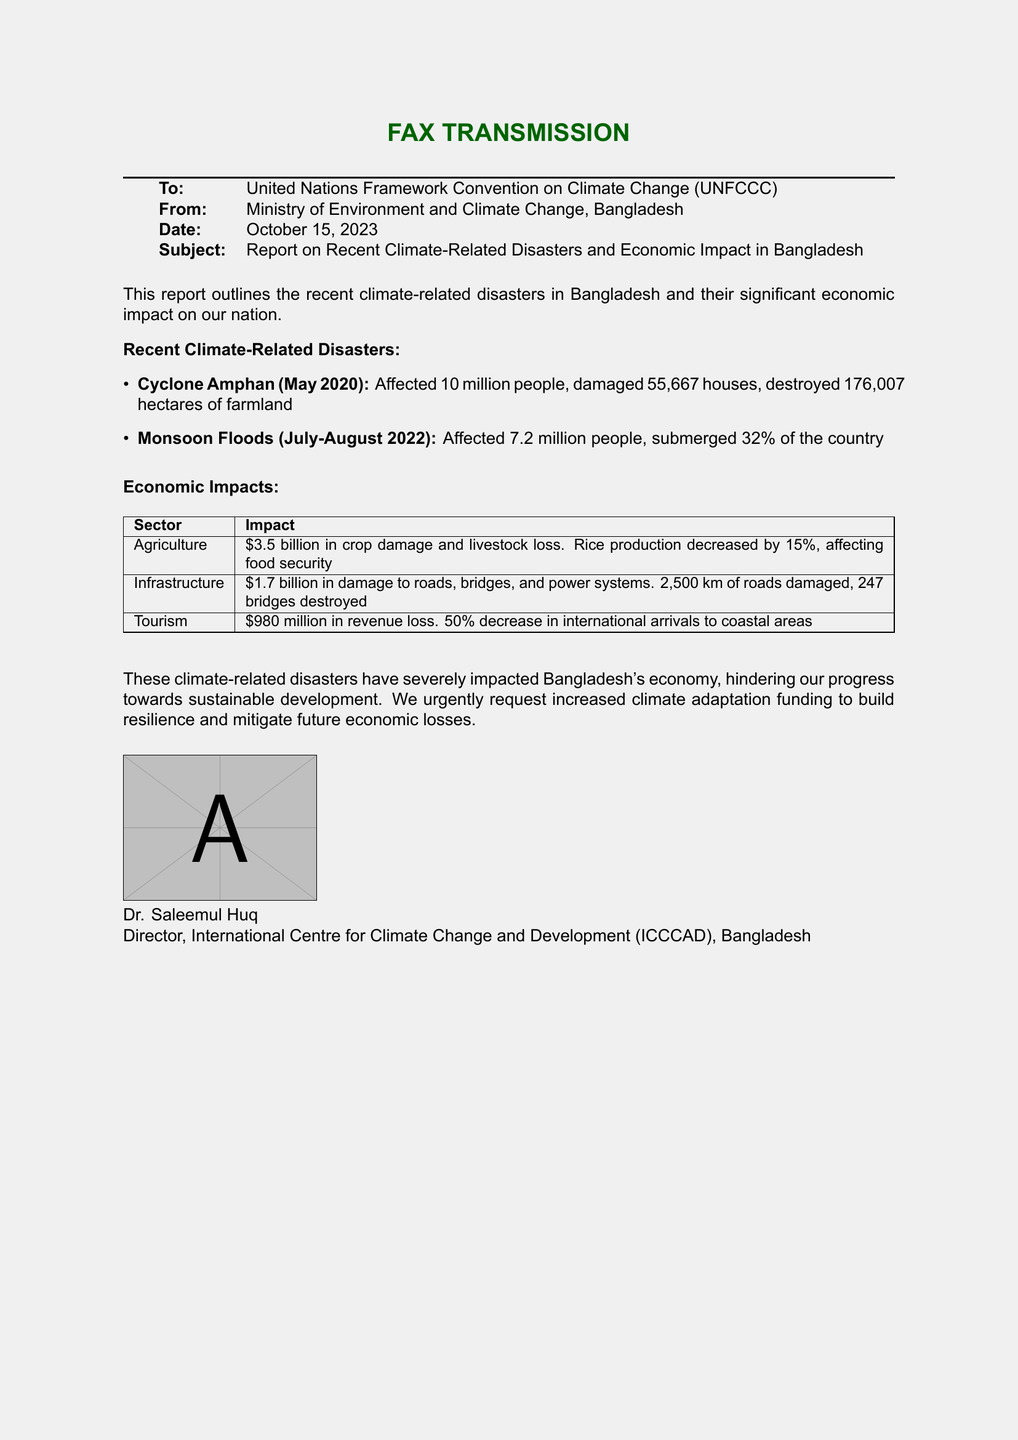what is the title of the report? The title is stated at the beginning of the report, which details climate-related disasters and economic impacts.
Answer: Report on Recent Climate-Related Disasters and Economic Impact in Bangladesh who is the sender of the fax? The sender is indicated in the header section of the document, specifying the governmental agency involved.
Answer: Ministry of Environment and Climate Change, Bangladesh when did Cyclone Amphan occur? The date of Cyclone Amphan is mentioned clearly under the recent climate-related disasters section.
Answer: May 2020 how many people were affected by the monsoon floods? The number of people affected is provided in the description of the monsoon floods event.
Answer: 7.2 million people what is the economic impact on agriculture? The impact on agriculture includes specific financial losses stated in the economic impacts table.
Answer: $3.5 billion in crop damage and livestock loss which sector experienced a $980 million revenue loss? The specific sector is noted in the economic impacts table under the corresponding loss amount.
Answer: Tourism what percentage of international arrivals to coastal areas decreased? The percentage decrease is provided in the tourism impact description.
Answer: 50% what is the total damage to infrastructure? The total damage to infrastructure is summarized in the economic impacts table.
Answer: $1.7 billion what is the request made by Bangladesh in the report? The report concludes with a request for funding, explicitly asking for support related to climate issues.
Answer: Increased climate adaptation funding 